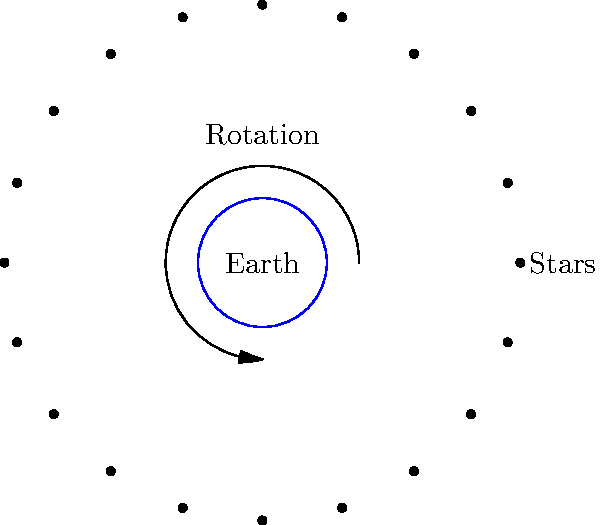As an industry analyst focused on sustainable technology, you're researching the impact of light pollution on astronomical observations. How does Earth's rotation affect the apparent motion of stars in the night sky, and what implications might this have for the design of energy-efficient outdoor lighting systems? To understand the apparent motion of stars due to Earth's rotation and its implications for lighting design, let's break it down step-by-step:

1. Earth's rotation:
   - Earth rotates on its axis from west to east, completing one full rotation in approximately 24 hours.
   - This rotation occurs at an angular speed of $\omega = \frac{2\pi}{24 \text{ hours}} \approx 0.26 \text{ rad/hour}$.

2. Apparent motion of stars:
   - Due to Earth's rotation, stars appear to move across the sky from east to west.
   - This motion is called diurnal motion.
   - The angular speed of this apparent motion is equal and opposite to Earth's rotation rate.

3. Path of stars:
   - Stars appear to trace circular paths around the celestial poles.
   - The North Celestial Pole is currently near Polaris (the North Star).
   - Stars closer to the celestial equator appear to move in larger circles.

4. Time to complete one apparent revolution:
   - Stars complete one full apparent revolution in approximately 23 hours and 56 minutes (a sidereal day).
   - This is slightly shorter than a solar day due to Earth's orbit around the Sun.

5. Implications for lighting design:
   - Light pollution can interfere with astronomical observations by reducing the visibility of stars.
   - Energy-efficient outdoor lighting systems should consider:
     a) Directional lighting to minimize upward light scatter.
     b) Using warmer color temperatures (lower blue light content) to reduce sky glow.
     c) Implementing timers or motion sensors to reduce unnecessary nighttime illumination.
     d) Designing fixtures that account for the changing position of stars throughout the night.

6. Sustainable technology considerations:
   - LED lighting technology offers energy efficiency and directional control.
   - Smart lighting systems can adjust brightness based on time of night and celestial events.
   - Dark sky compliant fixtures can minimize light pollution while maintaining safety and functionality.

By understanding the apparent motion of stars, lighting designers can create systems that balance human needs with preserving the night sky for astronomical observations and maintaining ecosystem health.
Answer: Earth's counterclockwise rotation causes stars to appear to move clockwise in the night sky, completing one revolution in 23 hours 56 minutes. This informs the design of directional, time-controlled, and spectrally-optimized outdoor lighting to minimize interference with astronomical observations. 